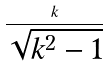<formula> <loc_0><loc_0><loc_500><loc_500>\frac { k } { \sqrt { k ^ { 2 } - 1 } }</formula> 